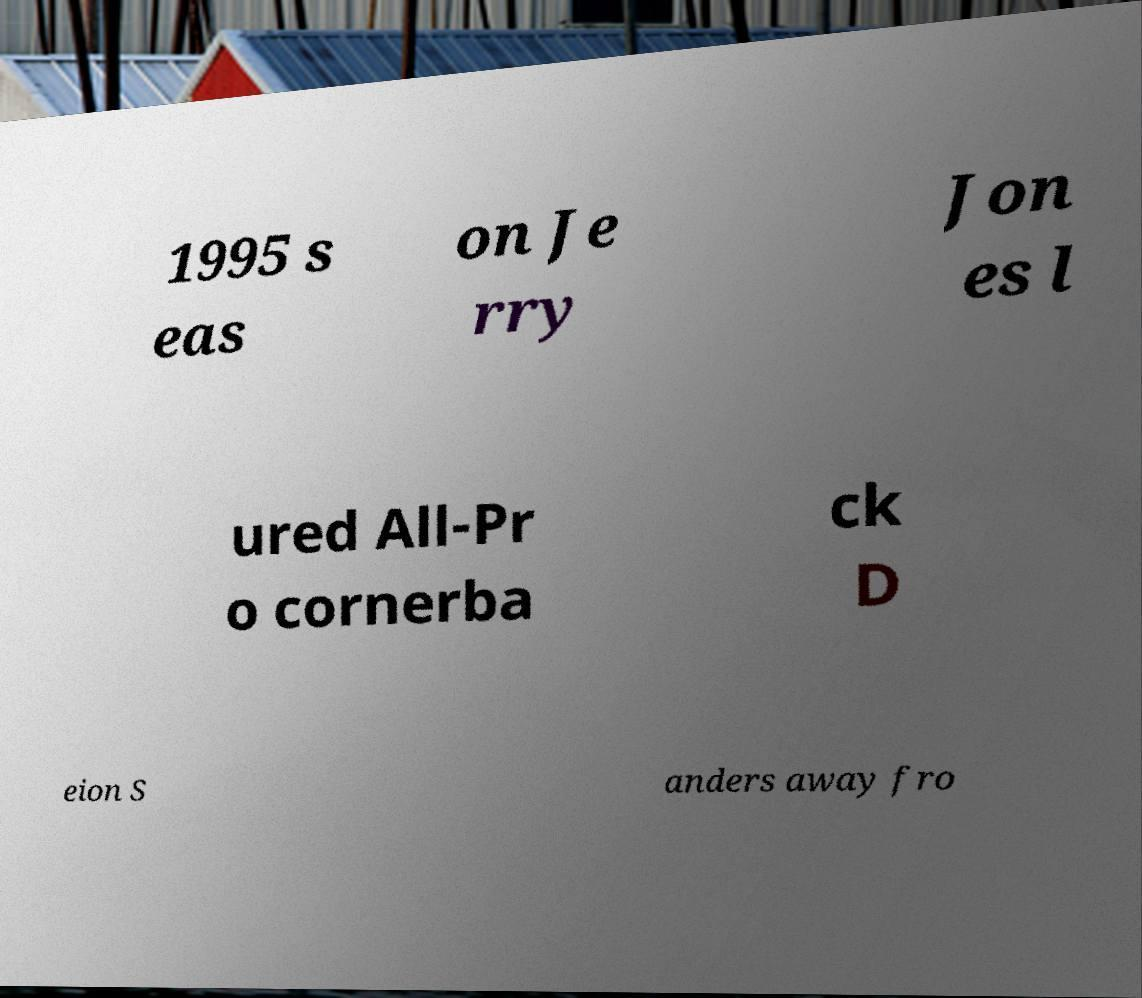There's text embedded in this image that I need extracted. Can you transcribe it verbatim? 1995 s eas on Je rry Jon es l ured All-Pr o cornerba ck D eion S anders away fro 